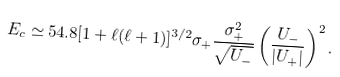Convert formula to latex. <formula><loc_0><loc_0><loc_500><loc_500>E _ { c } \simeq 5 4 . 8 [ 1 + \ell ( \ell + 1 ) ] ^ { 3 / 2 } \sigma _ { + } \frac { \sigma _ { + } ^ { 2 } } { { \sqrt { U _ { - } } } } \left ( \frac { U _ { - } } { | U _ { + } | } \right ) ^ { 2 } .</formula> 